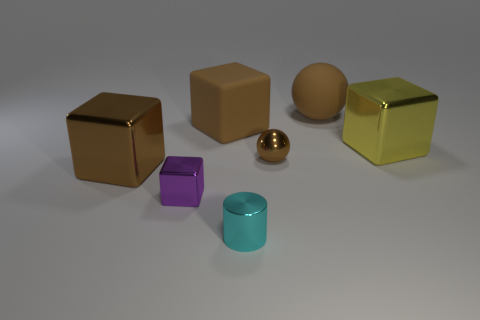Subtract all yellow cubes. How many cubes are left? 3 Subtract all tiny metal cubes. How many cubes are left? 3 Subtract all cyan blocks. Subtract all purple cylinders. How many blocks are left? 4 Add 3 tiny shiny spheres. How many objects exist? 10 Subtract all cylinders. How many objects are left? 6 Subtract all big objects. Subtract all tiny cyan things. How many objects are left? 2 Add 3 small cyan shiny cylinders. How many small cyan shiny cylinders are left? 4 Add 3 tiny brown metallic spheres. How many tiny brown metallic spheres exist? 4 Subtract 0 red balls. How many objects are left? 7 